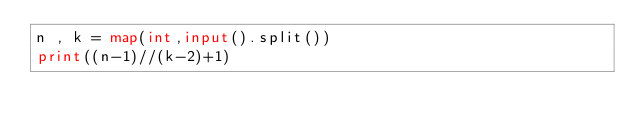Convert code to text. <code><loc_0><loc_0><loc_500><loc_500><_Python_>n , k = map(int,input().split())
print((n-1)//(k-2)+1)</code> 